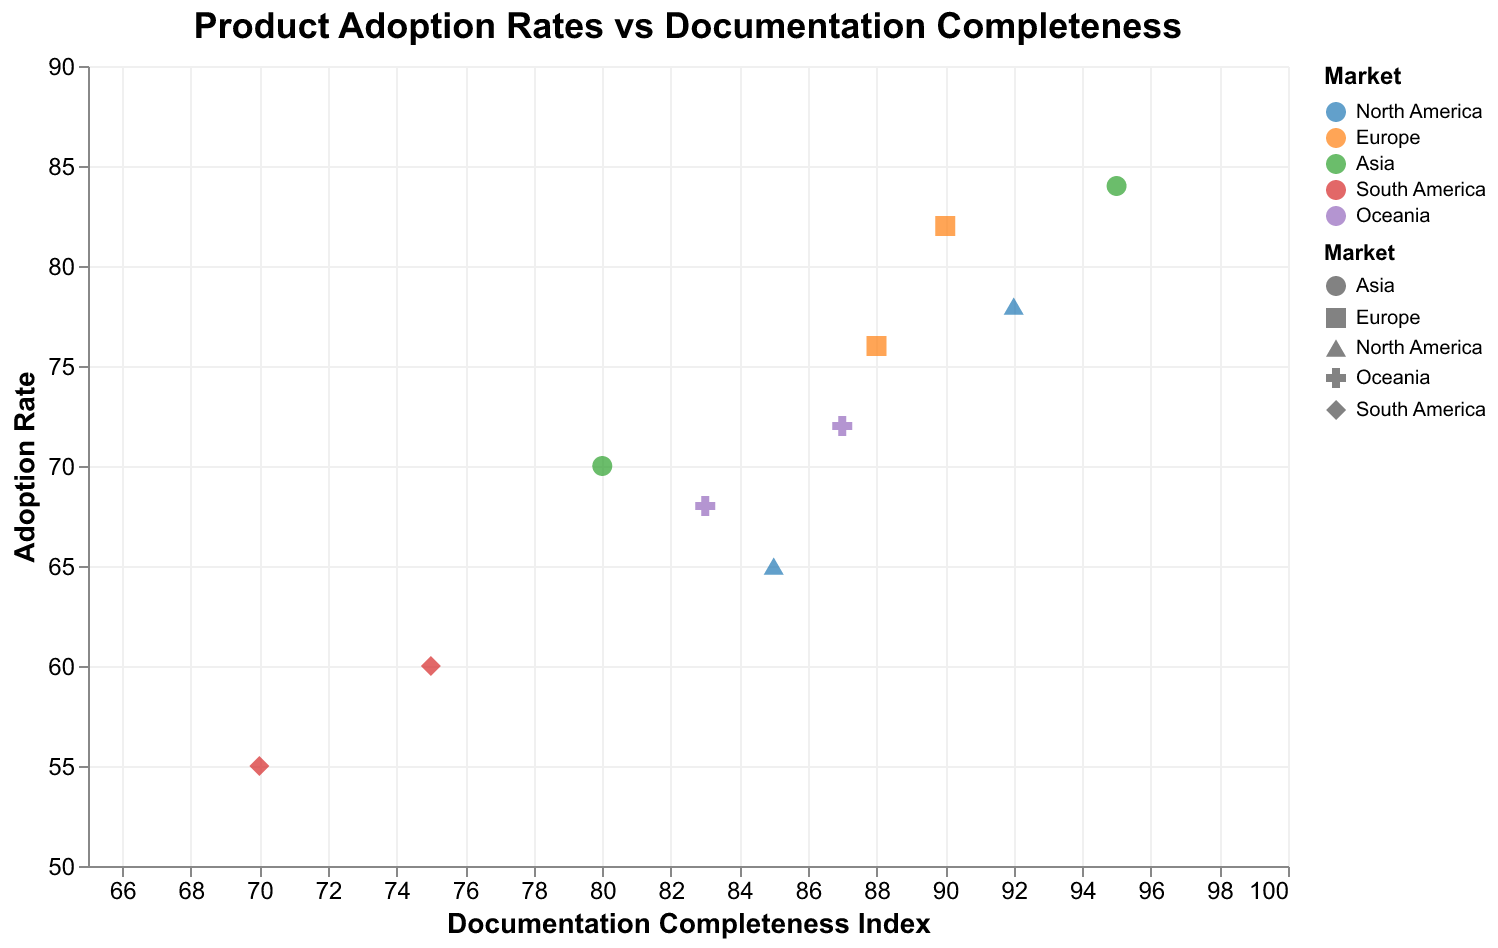What is the title of the plot? The title is usually displayed at the top of the plot, which for this plot is "Product Adoption Rates vs Documentation Completeness".
Answer: Product Adoption Rates vs Documentation Completeness Which market has the highest adoption rate and what is that rate? By scanning the y-axis for the highest value, and cross-referencing with the colors and data points, we can see that the highest adoption rate is in Asia (84), corresponding to Japan's Product E.
Answer: Asia, 84 What is the range of the Documentation Completeness Index shown in the plot? The range of the Documentation Completeness Index can be observed from the x-axis starting from the lowest value (70) to the highest value (95).
Answer: 70-95 Which product has the lowest adoption rate and what is the corresponding Documentation Completeness Index? By scanning the y-axis for the lowest value and finding the corresponding data point, we see Product H in Argentina has the lowest adoption rate (55) and a Documentation Completeness Index of 70.
Answer: Product H, 70 Compare the adoption rates of products in North America with those in Europe. Which region has a higher average adoption rate? North America has adoption rates of 78 (USA) and 65 (Canada), averaging (78+65)/2 = 71.5. Europe has adoption rates of 82 (Germany) and 76 (UK), averaging (82+76)/2 = 79. Therefore, Europe has a higher average adoption rate.
Answer: Europe Which market has the most variation in the adoption rates of their products? By examining the spread of the points within each market, South America has the most variation with Brazil at an adoption rate of 60 and Argentina at 55, showing a range of 5.
Answer: South America Is there a positive correlation between Documentation Completeness Index and Adoption Rate? By observing the overall pattern of the scatter points, we can see that as the Documentation Completeness Index increases, the Adoption Rate also tends to increase, indicating a positive correlation.
Answer: Yes Which country has a product with the highest Documentation Completeness Index? By looking at the x-axis for the highest value, Japan has the highest Documentation Completeness Index of 95 for Product E.
Answer: Japan What is the average Documentation Completeness Index for products in Oceania? Oceania contains Australia (83) and New Zealand (87). The average is calculated as (83+87)/2 = 85.
Answer: 85 In which market is the Documentation Completeness Index consistently below 80? By observing the data points and their corresponding Documentation Completeness Index, South America’s Brazil (75) and Argentina (70) both have values below 80.
Answer: South America 